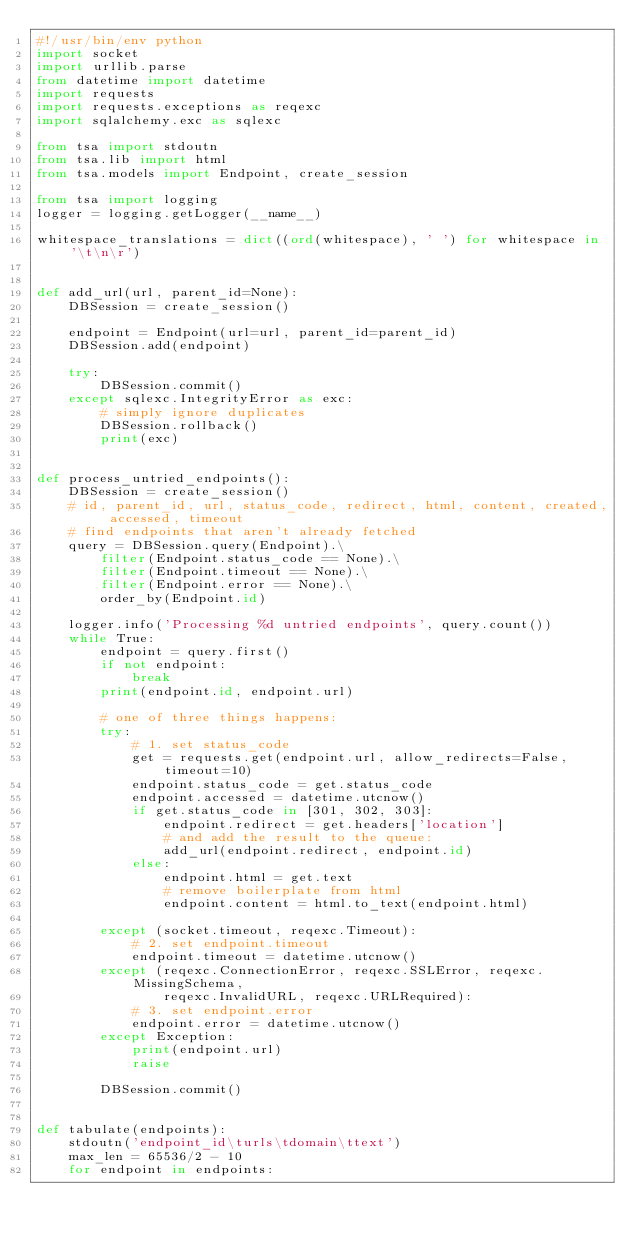Convert code to text. <code><loc_0><loc_0><loc_500><loc_500><_Python_>#!/usr/bin/env python
import socket
import urllib.parse
from datetime import datetime
import requests
import requests.exceptions as reqexc
import sqlalchemy.exc as sqlexc

from tsa import stdoutn
from tsa.lib import html
from tsa.models import Endpoint, create_session

from tsa import logging
logger = logging.getLogger(__name__)

whitespace_translations = dict((ord(whitespace), ' ') for whitespace in '\t\n\r')


def add_url(url, parent_id=None):
    DBSession = create_session()

    endpoint = Endpoint(url=url, parent_id=parent_id)
    DBSession.add(endpoint)

    try:
        DBSession.commit()
    except sqlexc.IntegrityError as exc:
        # simply ignore duplicates
        DBSession.rollback()
        print(exc)


def process_untried_endpoints():
    DBSession = create_session()
    # id, parent_id, url, status_code, redirect, html, content, created, accessed, timeout
    # find endpoints that aren't already fetched
    query = DBSession.query(Endpoint).\
        filter(Endpoint.status_code == None).\
        filter(Endpoint.timeout == None).\
        filter(Endpoint.error == None).\
        order_by(Endpoint.id)

    logger.info('Processing %d untried endpoints', query.count())
    while True:
        endpoint = query.first()
        if not endpoint:
            break
        print(endpoint.id, endpoint.url)

        # one of three things happens:
        try:
            # 1. set status_code
            get = requests.get(endpoint.url, allow_redirects=False, timeout=10)
            endpoint.status_code = get.status_code
            endpoint.accessed = datetime.utcnow()
            if get.status_code in [301, 302, 303]:
                endpoint.redirect = get.headers['location']
                # and add the result to the queue:
                add_url(endpoint.redirect, endpoint.id)
            else:
                endpoint.html = get.text
                # remove boilerplate from html
                endpoint.content = html.to_text(endpoint.html)

        except (socket.timeout, reqexc.Timeout):
            # 2. set endpoint.timeout
            endpoint.timeout = datetime.utcnow()
        except (reqexc.ConnectionError, reqexc.SSLError, reqexc.MissingSchema,
                reqexc.InvalidURL, reqexc.URLRequired):
            # 3. set endpoint.error
            endpoint.error = datetime.utcnow()
        except Exception:
            print(endpoint.url)
            raise

        DBSession.commit()


def tabulate(endpoints):
    stdoutn('endpoint_id\turls\tdomain\ttext')
    max_len = 65536/2 - 10
    for endpoint in endpoints:</code> 